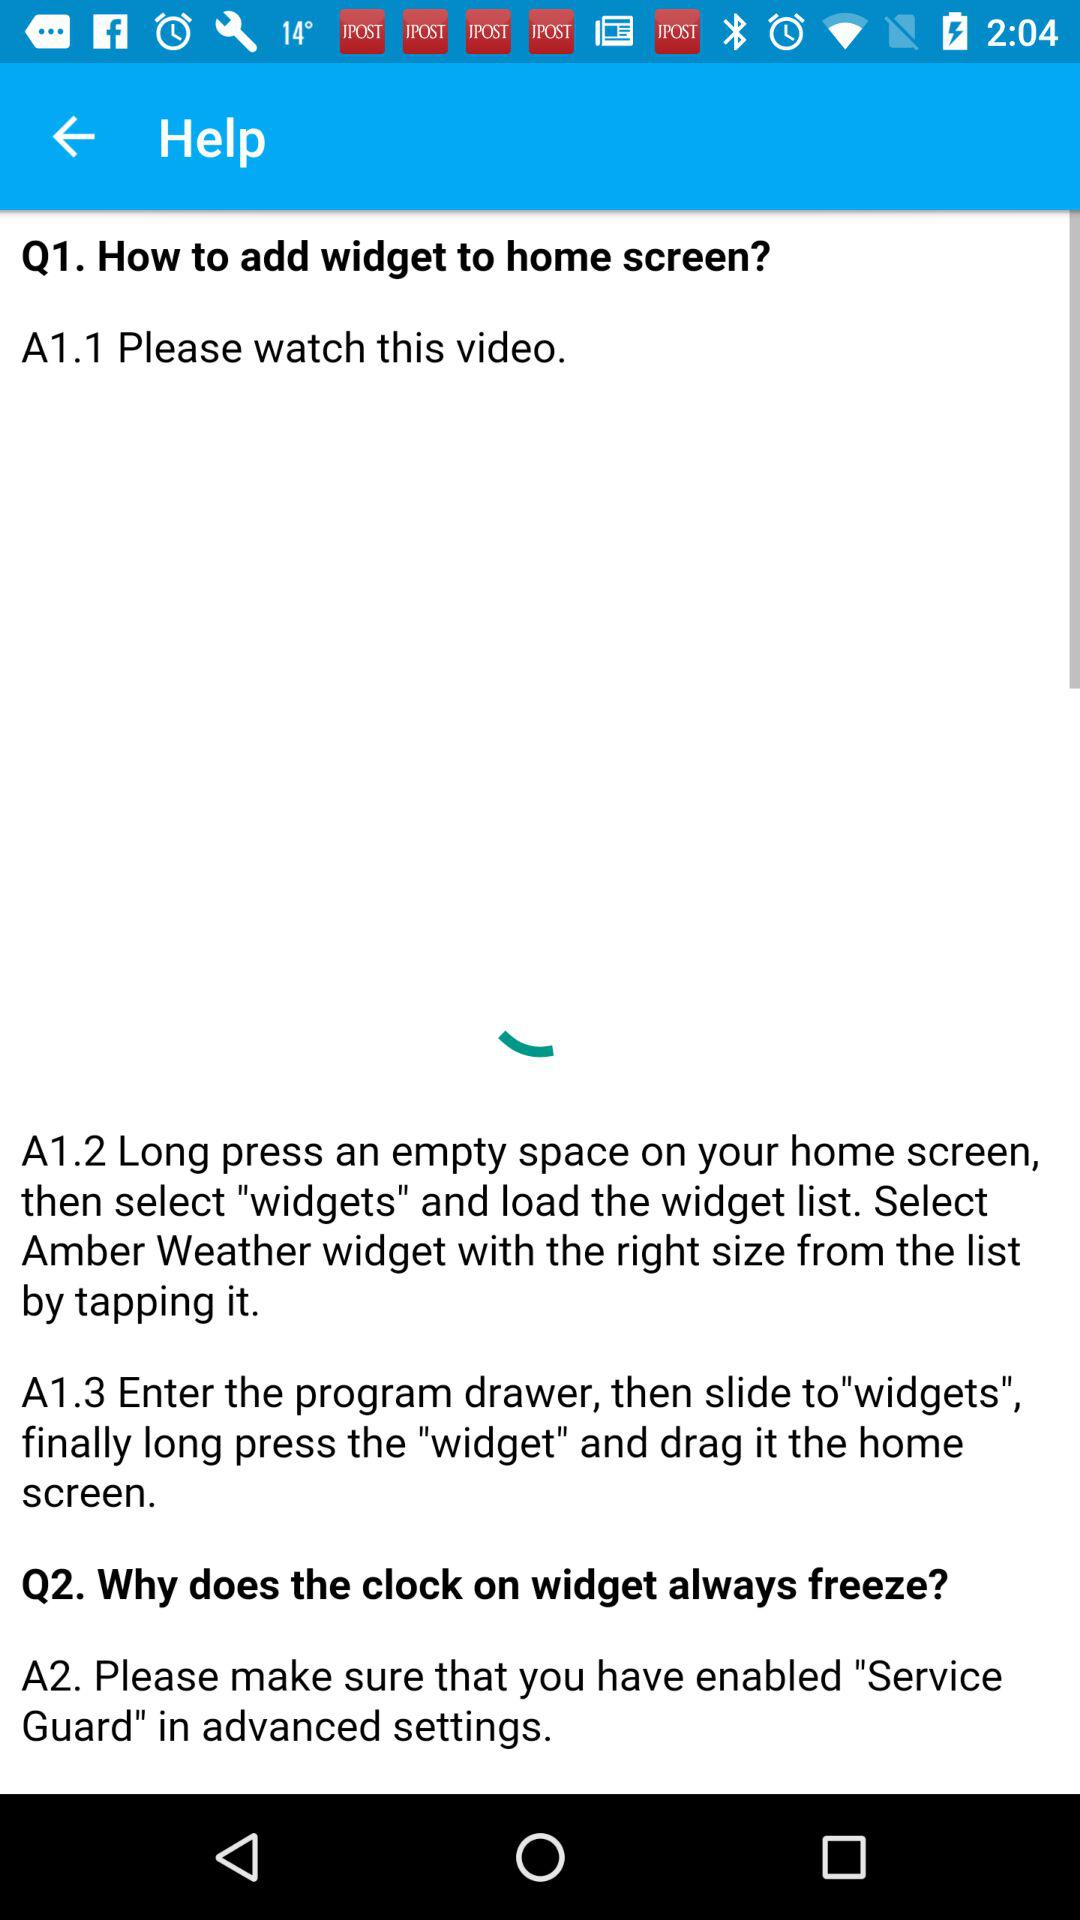How many steps are there to add a widget to the home screen?
Answer the question using a single word or phrase. 3 